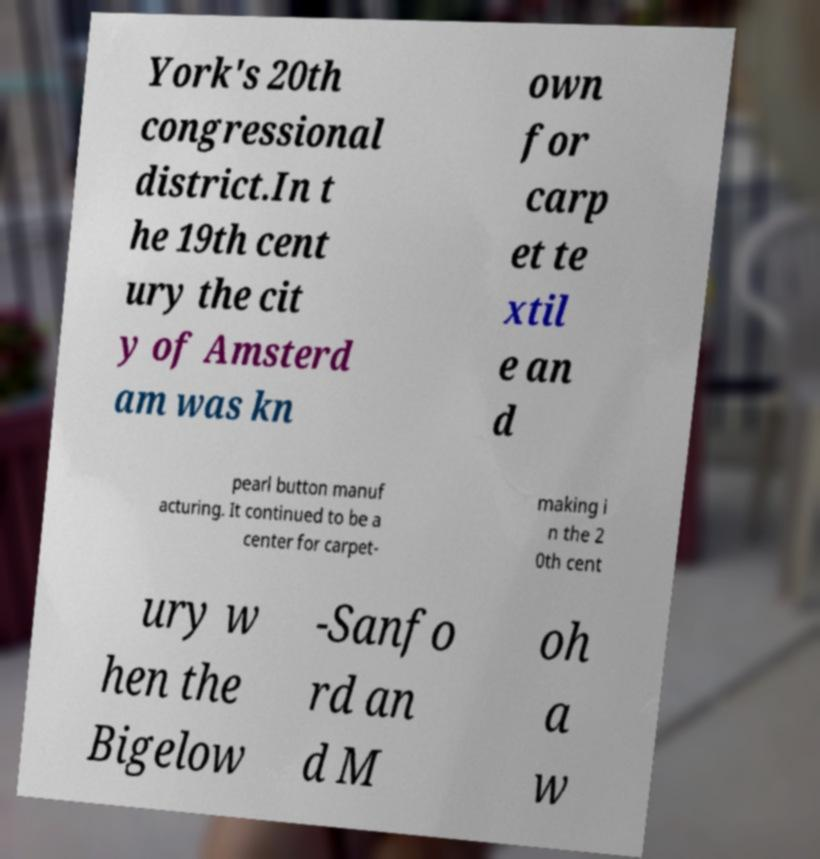Can you accurately transcribe the text from the provided image for me? York's 20th congressional district.In t he 19th cent ury the cit y of Amsterd am was kn own for carp et te xtil e an d pearl button manuf acturing. It continued to be a center for carpet- making i n the 2 0th cent ury w hen the Bigelow -Sanfo rd an d M oh a w 